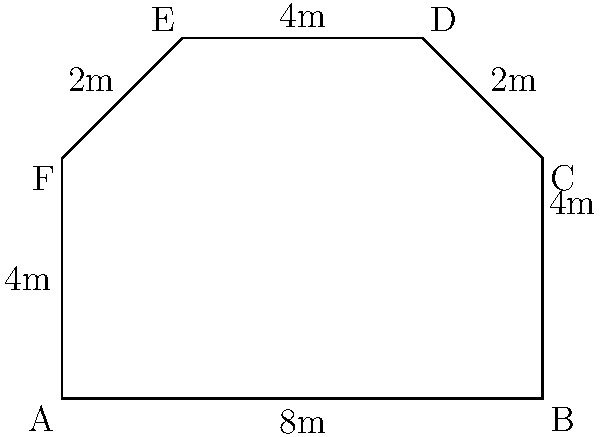As a screenwriter working closely with the director, you're tasked with calculating the area of an irregularly shaped film set. The set's boundaries form a hexagon with measurements as shown in the diagram. What is the total area of this film set in square meters? To find the area of this irregular hexagon, we can divide it into simpler shapes and sum their areas. Let's break it down step-by-step:

1. Divide the hexagon into a rectangle and two triangles.

2. Calculate the area of the rectangle:
   $A_{rectangle} = 8m \times 4m = 32m^2$

3. Calculate the area of the right triangle on the top right:
   $A_{triangle1} = \frac{1}{2} \times 2m \times 2m = 2m^2$

4. Calculate the area of the right triangle on the top left:
   $A_{triangle2} = \frac{1}{2} \times 2m \times 2m = 2m^2$

5. Sum up all the areas:
   $A_{total} = A_{rectangle} + A_{triangle1} + A_{triangle2}$
   $A_{total} = 32m^2 + 2m^2 + 2m^2 = 36m^2$

Therefore, the total area of the film set is 36 square meters.
Answer: 36 m² 